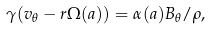<formula> <loc_0><loc_0><loc_500><loc_500>\gamma ( v _ { \theta } - r \Omega ( a ) ) = \alpha ( a ) B _ { \theta } / \rho ,</formula> 